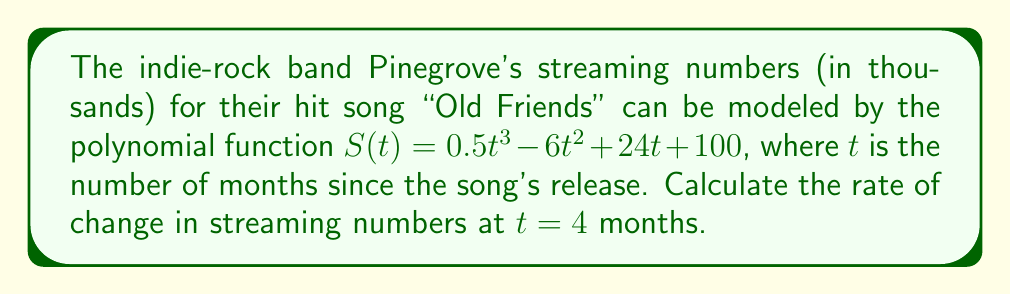Show me your answer to this math problem. To find the rate of change in streaming numbers at $t = 4$ months, we need to calculate the derivative of the given function $S(t)$ and then evaluate it at $t = 4$.

1. First, let's find the derivative of $S(t)$:
   
   $S(t) = 0.5t^3 - 6t^2 + 24t + 100$
   
   $S'(t) = \frac{d}{dt}(0.5t^3 - 6t^2 + 24t + 100)$
   
   $S'(t) = 1.5t^2 - 12t + 24$

2. Now, we need to evaluate $S'(t)$ at $t = 4$:
   
   $S'(4) = 1.5(4)^2 - 12(4) + 24$
   
   $S'(4) = 1.5(16) - 48 + 24$
   
   $S'(4) = 24 - 48 + 24$
   
   $S'(4) = 0$

3. The rate of change at $t = 4$ is given by $S'(4)$, which we calculated to be 0.

This means that at exactly 4 months after the release, the streaming numbers for "Old Friends" are neither increasing nor decreasing. This point represents a local maximum or minimum in the streaming numbers.
Answer: The rate of change in streaming numbers at $t = 4$ months is 0 thousand streams per month. 